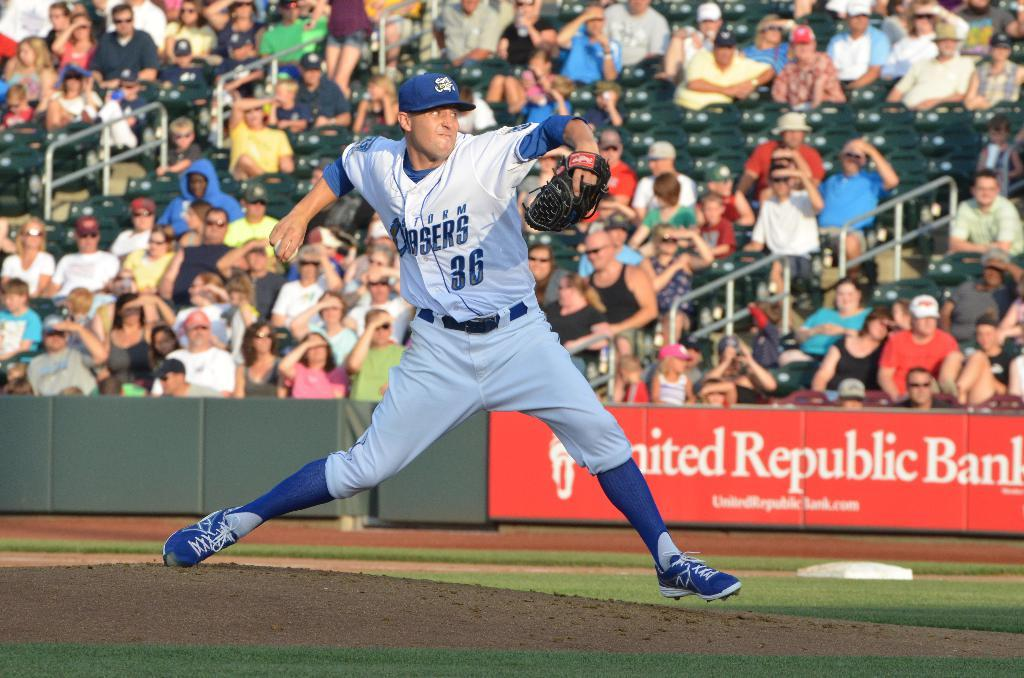<image>
Present a compact description of the photo's key features. Number 36 of the Storm Chasers is pitching on the mound. 